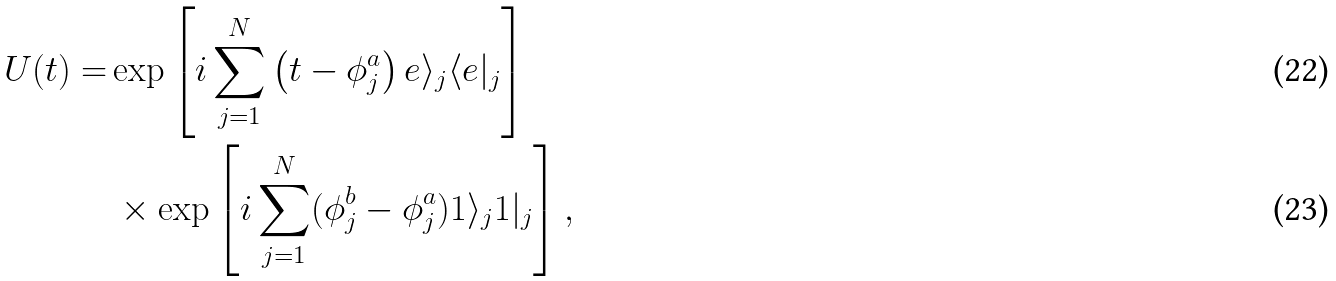Convert formula to latex. <formula><loc_0><loc_0><loc_500><loc_500>U ( t ) = & \exp \left [ i \sum _ { j = 1 } ^ { N } \left ( t - \phi ^ { a } _ { j } \right ) e \rangle _ { j } \langle e | _ { j } \right ] \\ & \, \times \exp \left [ i \sum _ { j = 1 } ^ { N } ( \phi ^ { b } _ { j } - \phi ^ { a } _ { j } ) 1 \rangle _ { j } 1 | _ { j } \right ] ,</formula> 